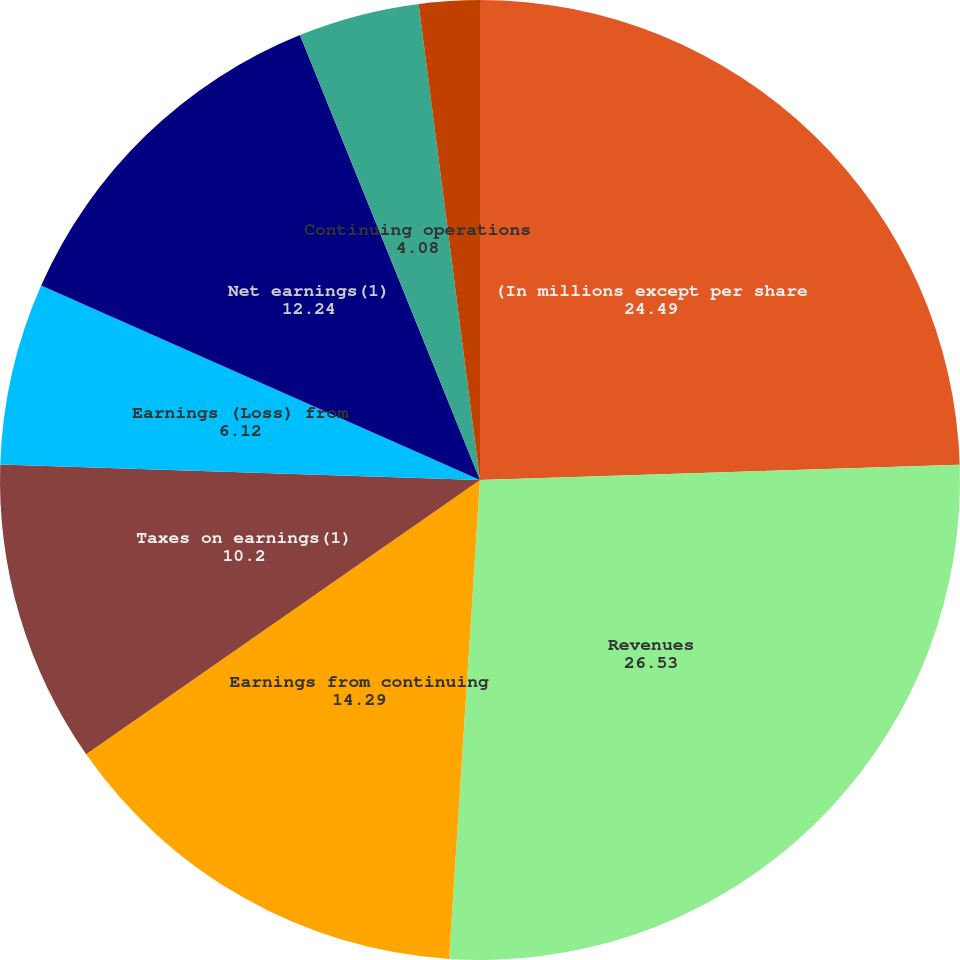Convert chart to OTSL. <chart><loc_0><loc_0><loc_500><loc_500><pie_chart><fcel>(In millions except per share<fcel>Revenues<fcel>Earnings from continuing<fcel>Taxes on earnings(1)<fcel>Earnings (Loss) from<fcel>Net earnings(1)<fcel>Continuing operations<fcel>Discontininued operations(2)<fcel>Net earnings per share<nl><fcel>24.49%<fcel>26.53%<fcel>14.29%<fcel>10.2%<fcel>6.12%<fcel>12.24%<fcel>4.08%<fcel>0.0%<fcel>2.04%<nl></chart> 